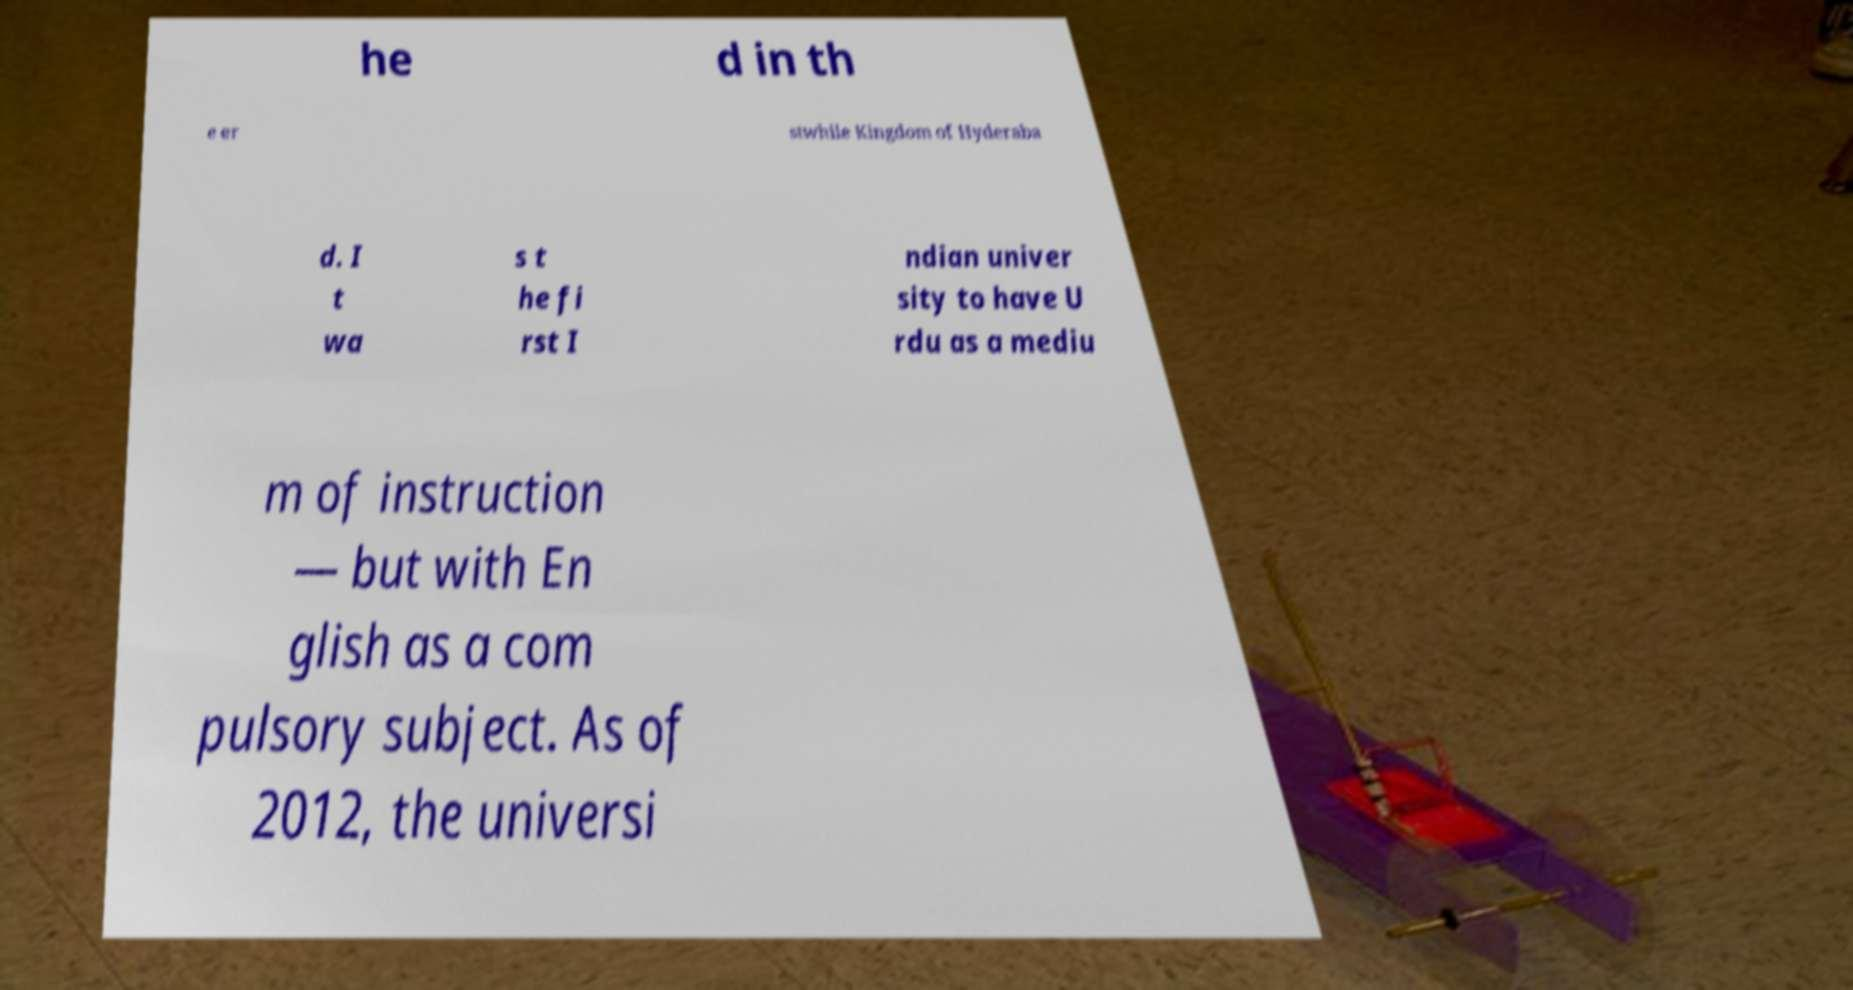Could you extract and type out the text from this image? he d in th e er stwhile Kingdom of Hyderaba d. I t wa s t he fi rst I ndian univer sity to have U rdu as a mediu m of instruction — but with En glish as a com pulsory subject. As of 2012, the universi 